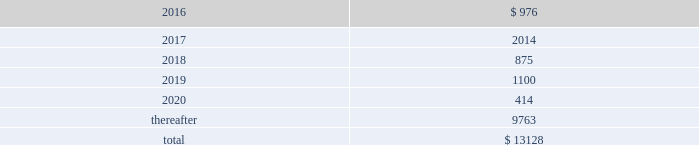Devon energy corporation and subsidiaries notes to consolidated financial statements 2013 ( continued ) debt maturities as of december 31 , 2015 , excluding premiums and discounts , are as follows ( millions ) : .
Credit lines devon has a $ 3.0 billion senior credit facility .
The maturity date for $ 30 million of the senior credit facility is october 24 , 2017 .
The maturity date for $ 164 million of the senior credit facility is october 24 , 2018 .
The maturity date for the remaining $ 2.8 billion is october 24 , 2019 .
Amounts borrowed under the senior credit facility may , at the election of devon , bear interest at various fixed rate options for periods of up to twelve months .
Such rates are generally less than the prime rate .
However , devon may elect to borrow at the prime rate .
The senior credit facility currently provides for an annual facility fee of $ 3.8 million that is payable quarterly in arrears .
As of december 31 , 2015 , there were no borrowings under the senior credit facility .
The senior credit facility contains only one material financial covenant .
This covenant requires devon 2019s ratio of total funded debt to total capitalization , as defined in the credit agreement , to be no greater than 65% ( 65 % ) .
The credit agreement contains definitions of total funded debt and total capitalization that include adjustments to the respective amounts reported in the accompanying consolidated financial statements .
Also , total capitalization is adjusted to add back noncash financial write-downs such as full cost ceiling impairments or goodwill impairments .
As of december 31 , 2015 , devon was in compliance with this covenant with a debt-to- capitalization ratio of 23.7% ( 23.7 % ) .
Commercial paper devon 2019s senior credit facility supports its $ 3.0 billion of short-term credit under its commercial paper program .
Commercial paper debt generally has a maturity of between 1 and 90 days , although it can have a maturity of up to 365 days , and bears interest at rates agreed to at the time of the borrowing .
The interest rate is generally based on a standard index such as the federal funds rate , libor or the money market rate as found in the commercial paper market .
As of december 31 , 2015 , devon 2019s outstanding commercial paper borrowings had a weighted-average borrowing rate of 0.63% ( 0.63 % ) .
Issuance of senior notes in june 2015 , devon issued $ 750 million of 5.0% ( 5.0 % ) senior notes due 2045 that are unsecured and unsubordinated obligations .
Devon used the net proceeds to repay the floating rate senior notes that matured on december 15 , 2015 , as well as outstanding commercial paper balances .
In december 2015 , in conjunction with the announcement of the powder river basin and stack acquisitions , devon issued $ 850 million of 5.85% ( 5.85 % ) senior notes due 2025 that are unsecured and unsubordinated obligations .
Devon used the net proceeds to fund the cash portion of these acquisitions. .
In millions , what was the mathematical range of debt maturities for 2018-2020? 
Computations: (1100 - 414)
Answer: 686.0. 